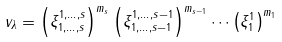<formula> <loc_0><loc_0><loc_500><loc_500>v _ { \lambda } = \left ( \xi _ { 1 , \dots , s } ^ { 1 , \dots , s } \right ) ^ { m _ { s } } \left ( \xi _ { 1 , \dots , s - 1 } ^ { 1 , \dots , s - 1 } \right ) ^ { m _ { s - 1 } } \cdots \left ( \xi _ { 1 } ^ { 1 } \right ) ^ { m _ { 1 } }</formula> 